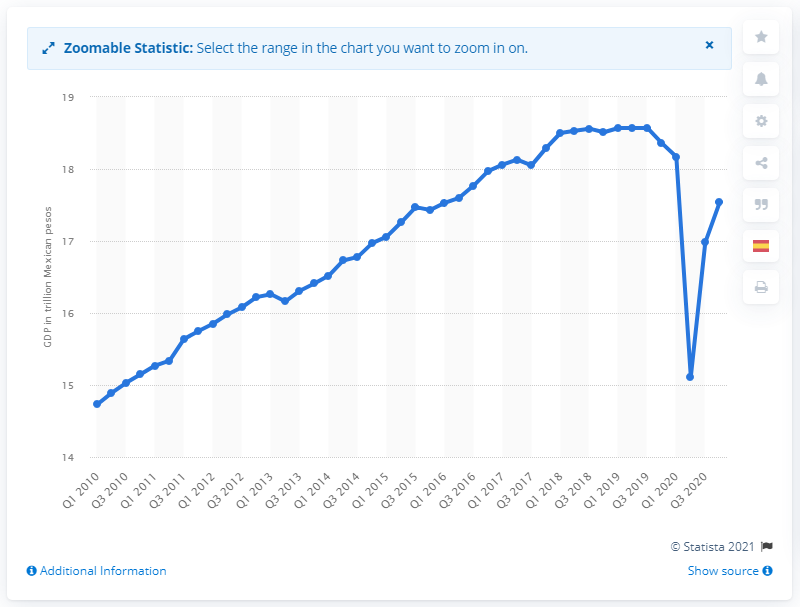Specify some key components in this picture. In the second quarter of 2020, the gross domestic product of Mexico was 15.11. 